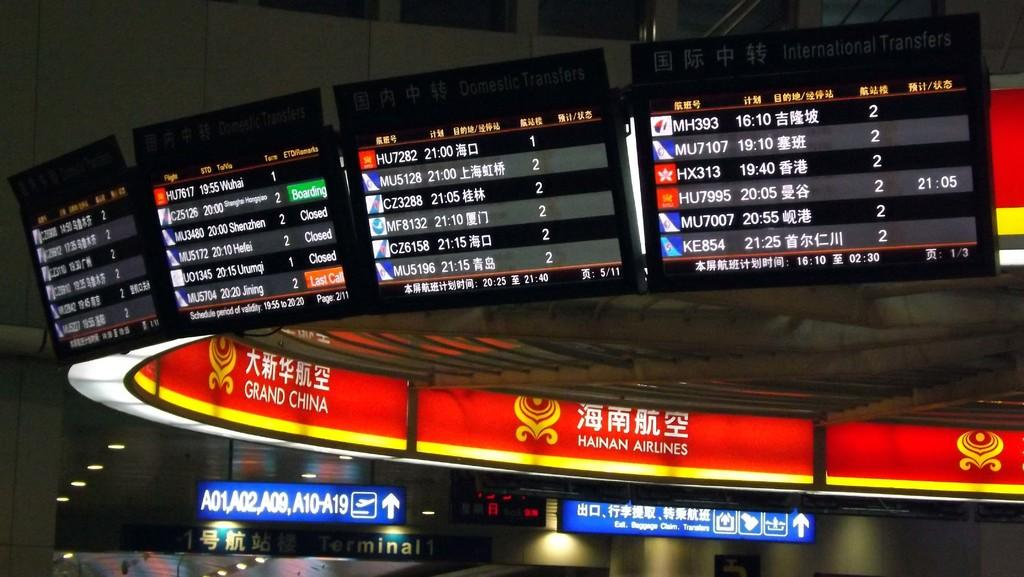<image>
Relay a brief, clear account of the picture shown. the word airlines is on the red sign 